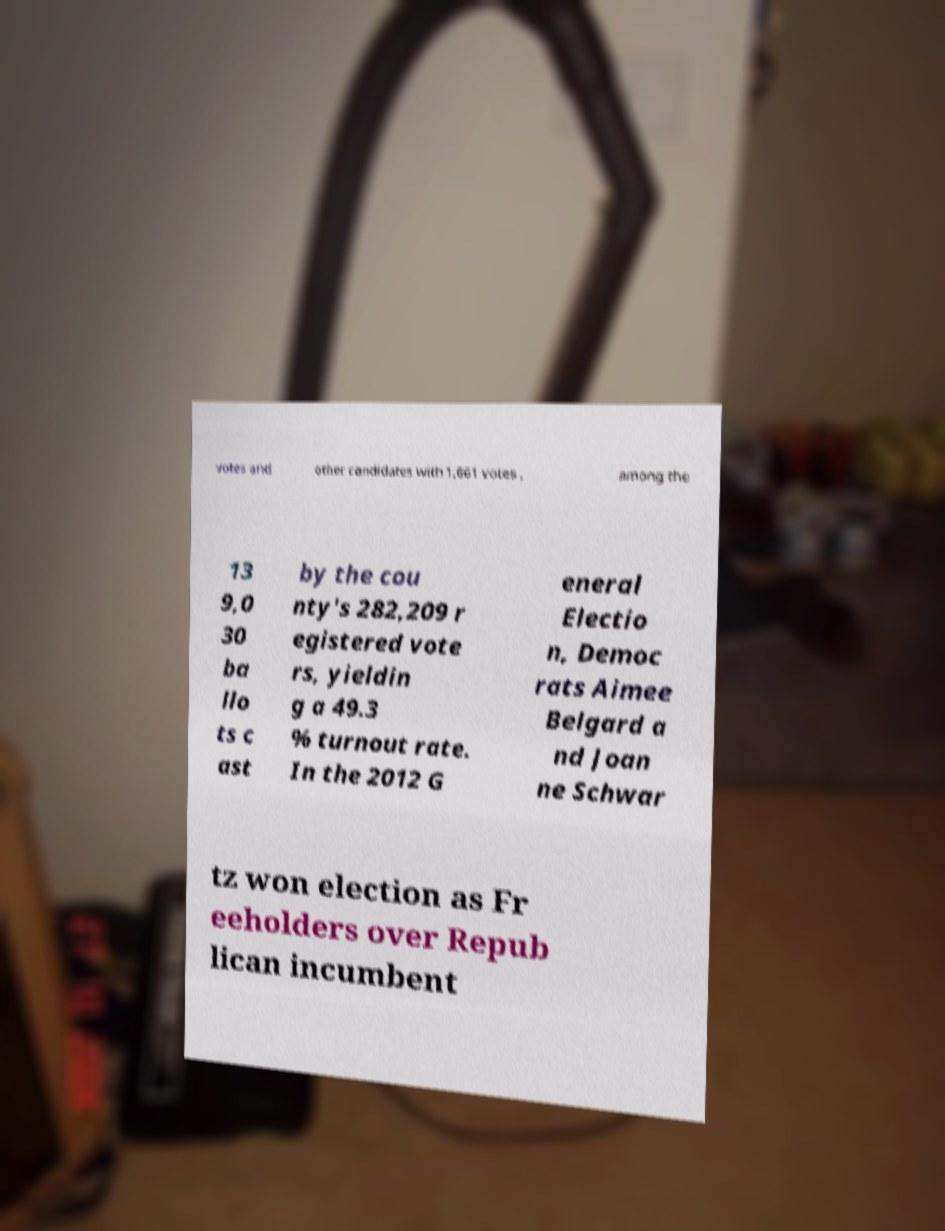For documentation purposes, I need the text within this image transcribed. Could you provide that? votes and other candidates with 1,661 votes , among the 13 9,0 30 ba llo ts c ast by the cou nty's 282,209 r egistered vote rs, yieldin g a 49.3 % turnout rate. In the 2012 G eneral Electio n, Democ rats Aimee Belgard a nd Joan ne Schwar tz won election as Fr eeholders over Repub lican incumbent 